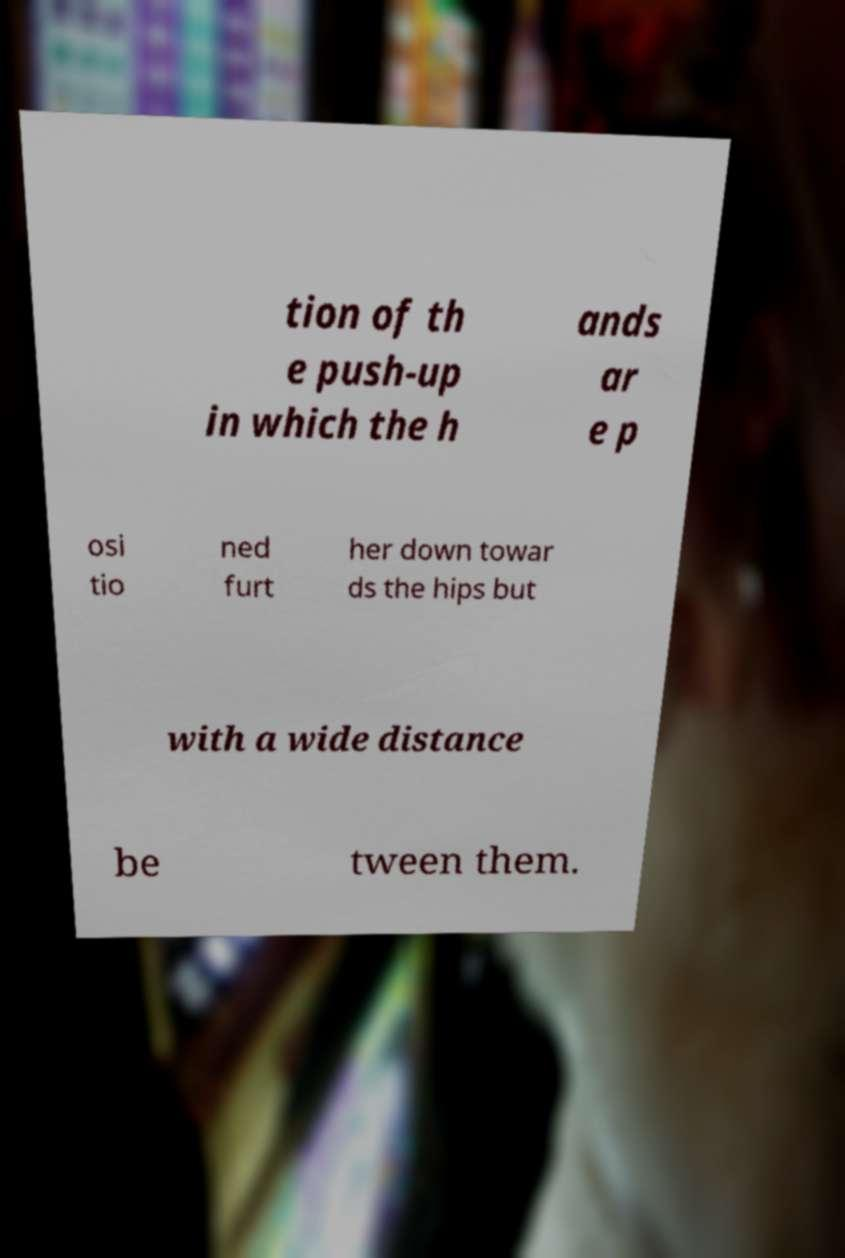Please identify and transcribe the text found in this image. tion of th e push-up in which the h ands ar e p osi tio ned furt her down towar ds the hips but with a wide distance be tween them. 